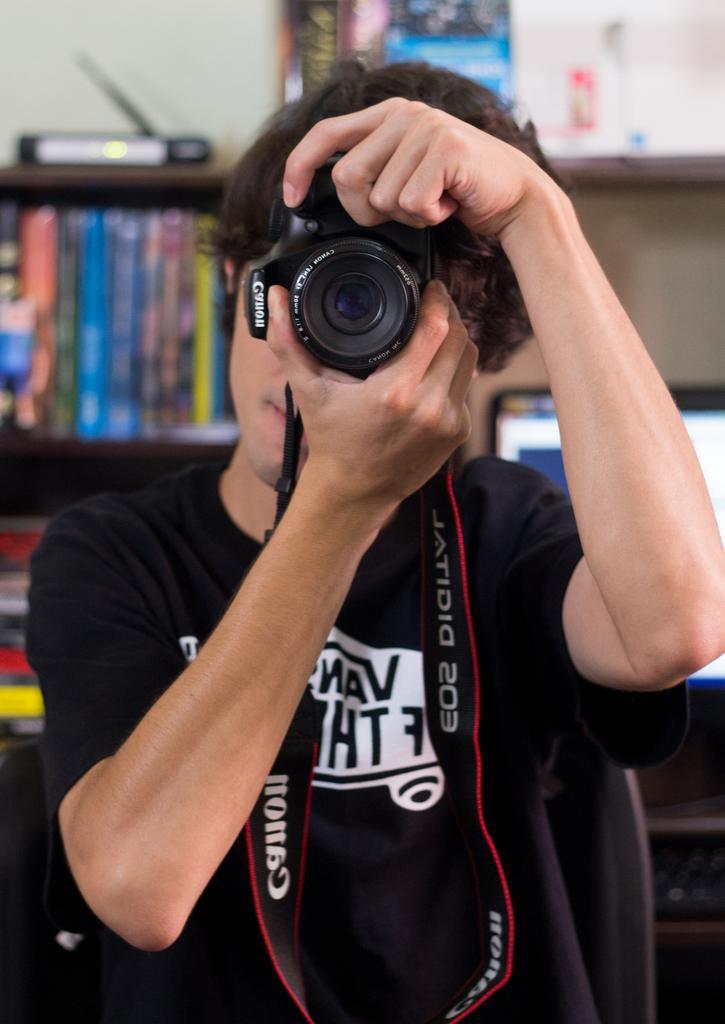Describe this image in one or two sentences. In the picture we can see a man with a black T-shirt and holding a camera which is black in color with a tag and he is capturing something with a camera and in the background, we can see some rocks with full of books and top of it we can see a set up box. 